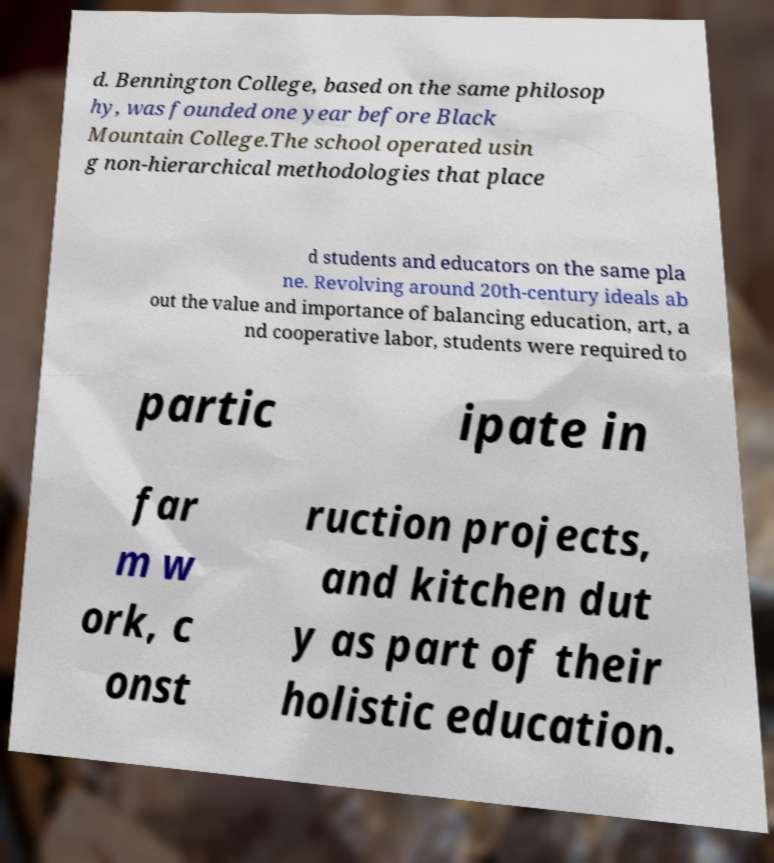What messages or text are displayed in this image? I need them in a readable, typed format. d. Bennington College, based on the same philosop hy, was founded one year before Black Mountain College.The school operated usin g non-hierarchical methodologies that place d students and educators on the same pla ne. Revolving around 20th-century ideals ab out the value and importance of balancing education, art, a nd cooperative labor, students were required to partic ipate in far m w ork, c onst ruction projects, and kitchen dut y as part of their holistic education. 